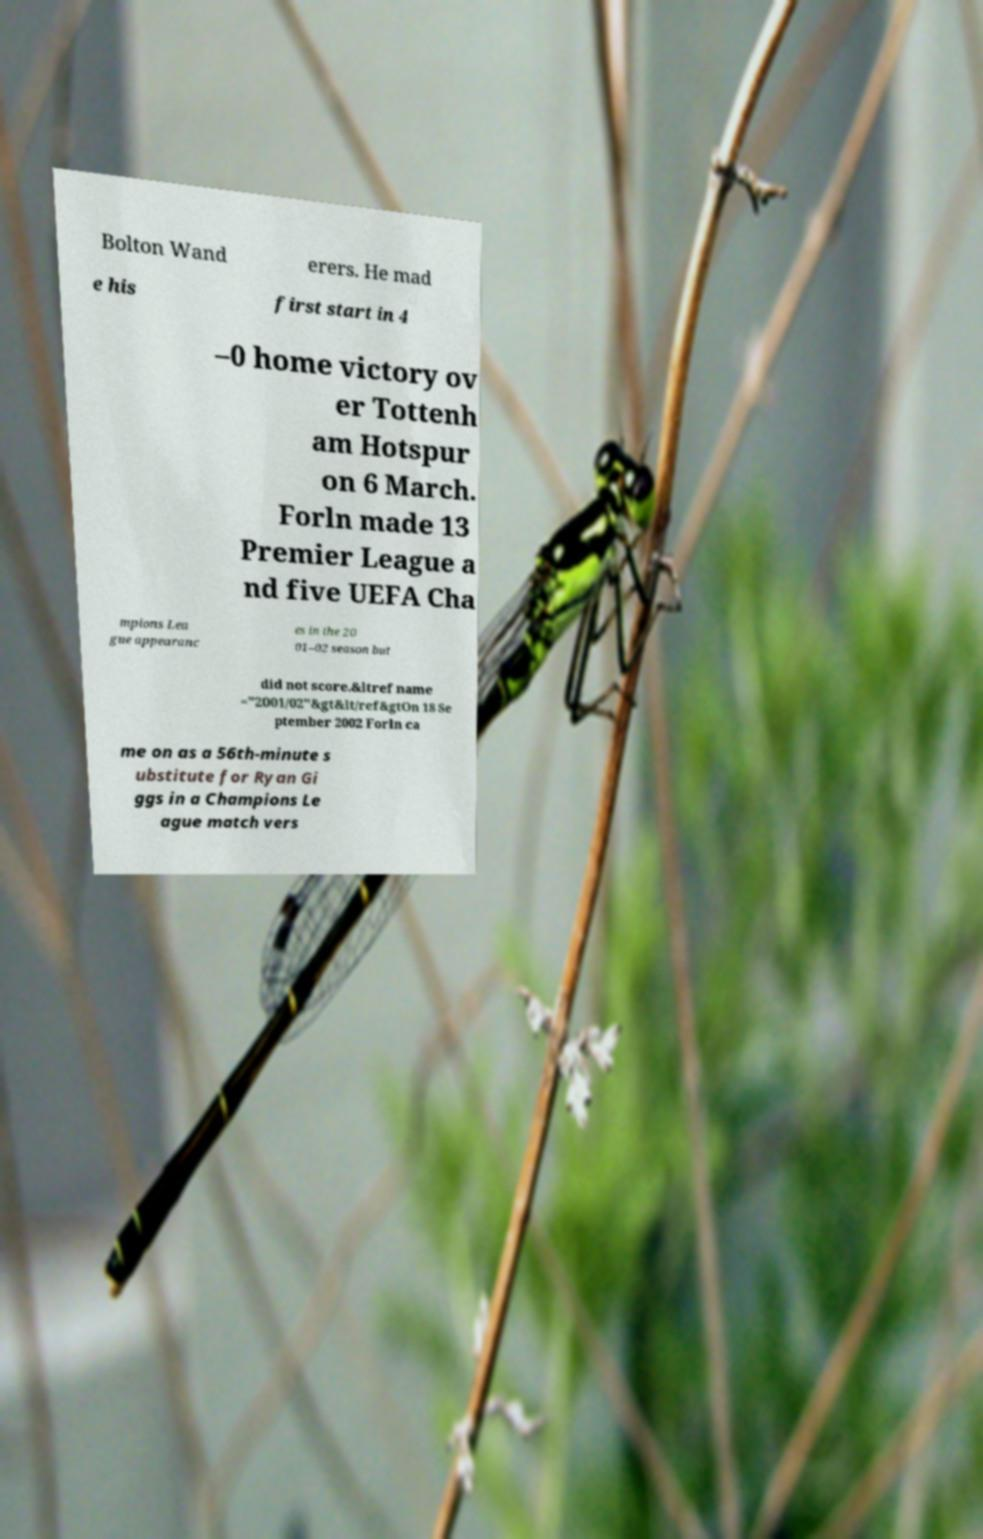Can you accurately transcribe the text from the provided image for me? Bolton Wand erers. He mad e his first start in 4 –0 home victory ov er Tottenh am Hotspur on 6 March. Forln made 13 Premier League a nd five UEFA Cha mpions Lea gue appearanc es in the 20 01–02 season but did not score.&ltref name ="2001/02"&gt&lt/ref&gtOn 18 Se ptember 2002 Forln ca me on as a 56th-minute s ubstitute for Ryan Gi ggs in a Champions Le ague match vers 